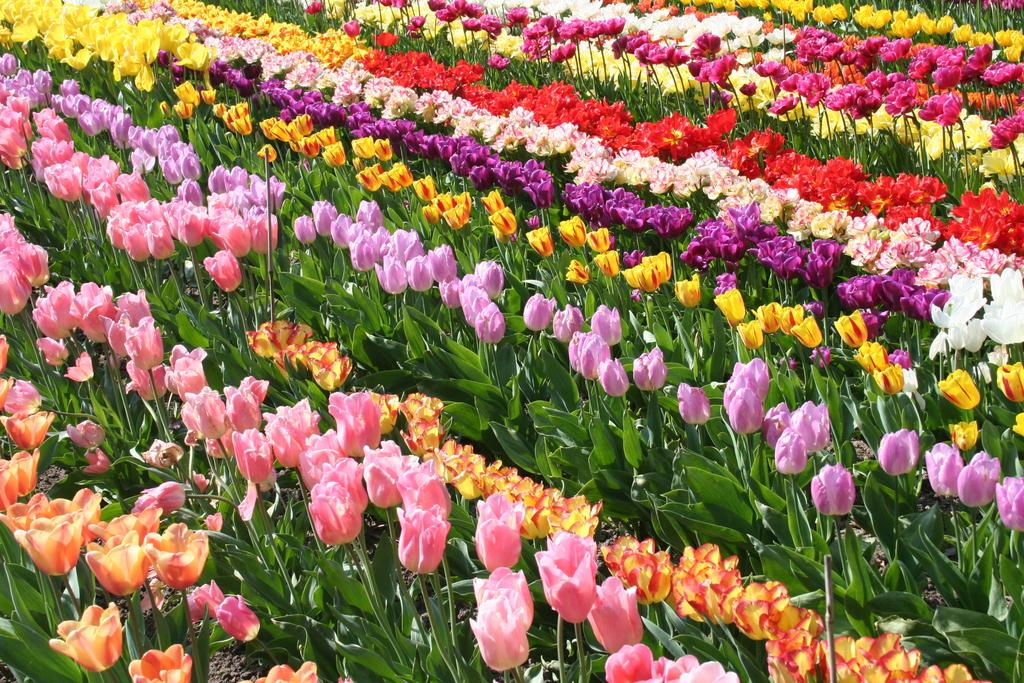What type of living organisms can be seen in the image? Plants can be seen in the image. What specific feature of the plants is mentioned in the facts? The plants have colorful flowers. Are there any other objects present in the image besides the plants? Yes, there are wooden sticks in the image. How many jellyfish can be seen swimming in the image? There are no jellyfish present in the image; it features plants with colorful flowers and wooden sticks. What type of clothing are the boys wearing in the image? There are no boys present in the image; it only contains plants, colorful flowers, and wooden sticks. 